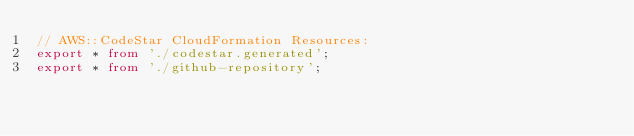<code> <loc_0><loc_0><loc_500><loc_500><_TypeScript_>// AWS::CodeStar CloudFormation Resources:
export * from './codestar.generated';
export * from './github-repository';
</code> 